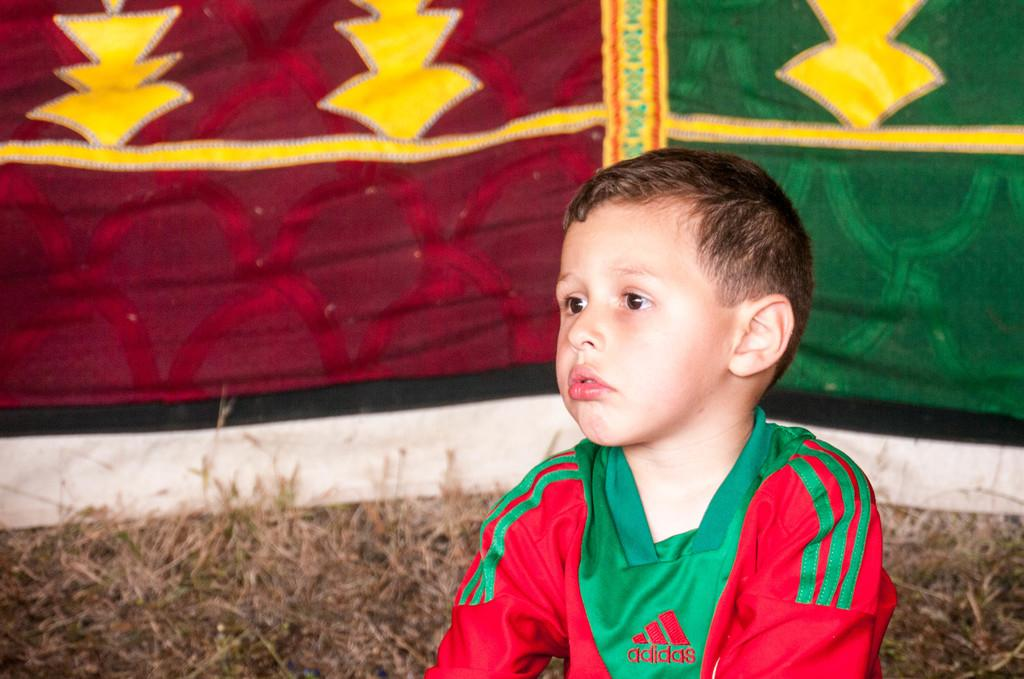What is the main subject in the image? There is a boy sitting in the image. What type of environment is depicted in the image? There is dried grass in the image. What can be seen in the background of the image? There is a cloth visible in the background of the image. What type of collar can be seen on the butter in the image? There is no butter or collar present in the image. 